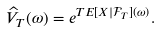<formula> <loc_0><loc_0><loc_500><loc_500>\widehat { V } _ { T } ( \omega ) = e ^ { T E [ X | \mathcal { F } _ { T } ] ( \omega ) } .</formula> 